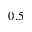Convert formula to latex. <formula><loc_0><loc_0><loc_500><loc_500>0 . 5</formula> 